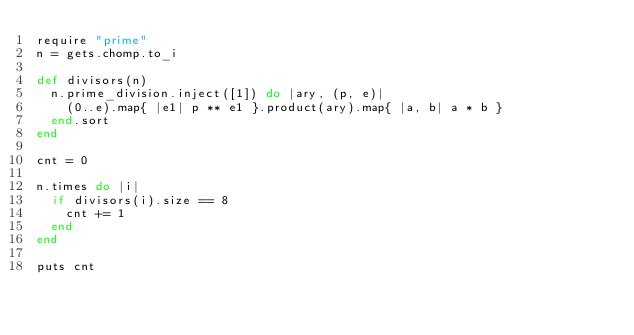<code> <loc_0><loc_0><loc_500><loc_500><_Ruby_>require "prime"
n = gets.chomp.to_i

def divisors(n)
  n.prime_division.inject([1]) do |ary, (p, e)|
    (0..e).map{ |e1| p ** e1 }.product(ary).map{ |a, b| a * b }
  end.sort
end

cnt = 0

n.times do |i|
  if divisors(i).size == 8
    cnt += 1
  end
end

puts cnt
</code> 